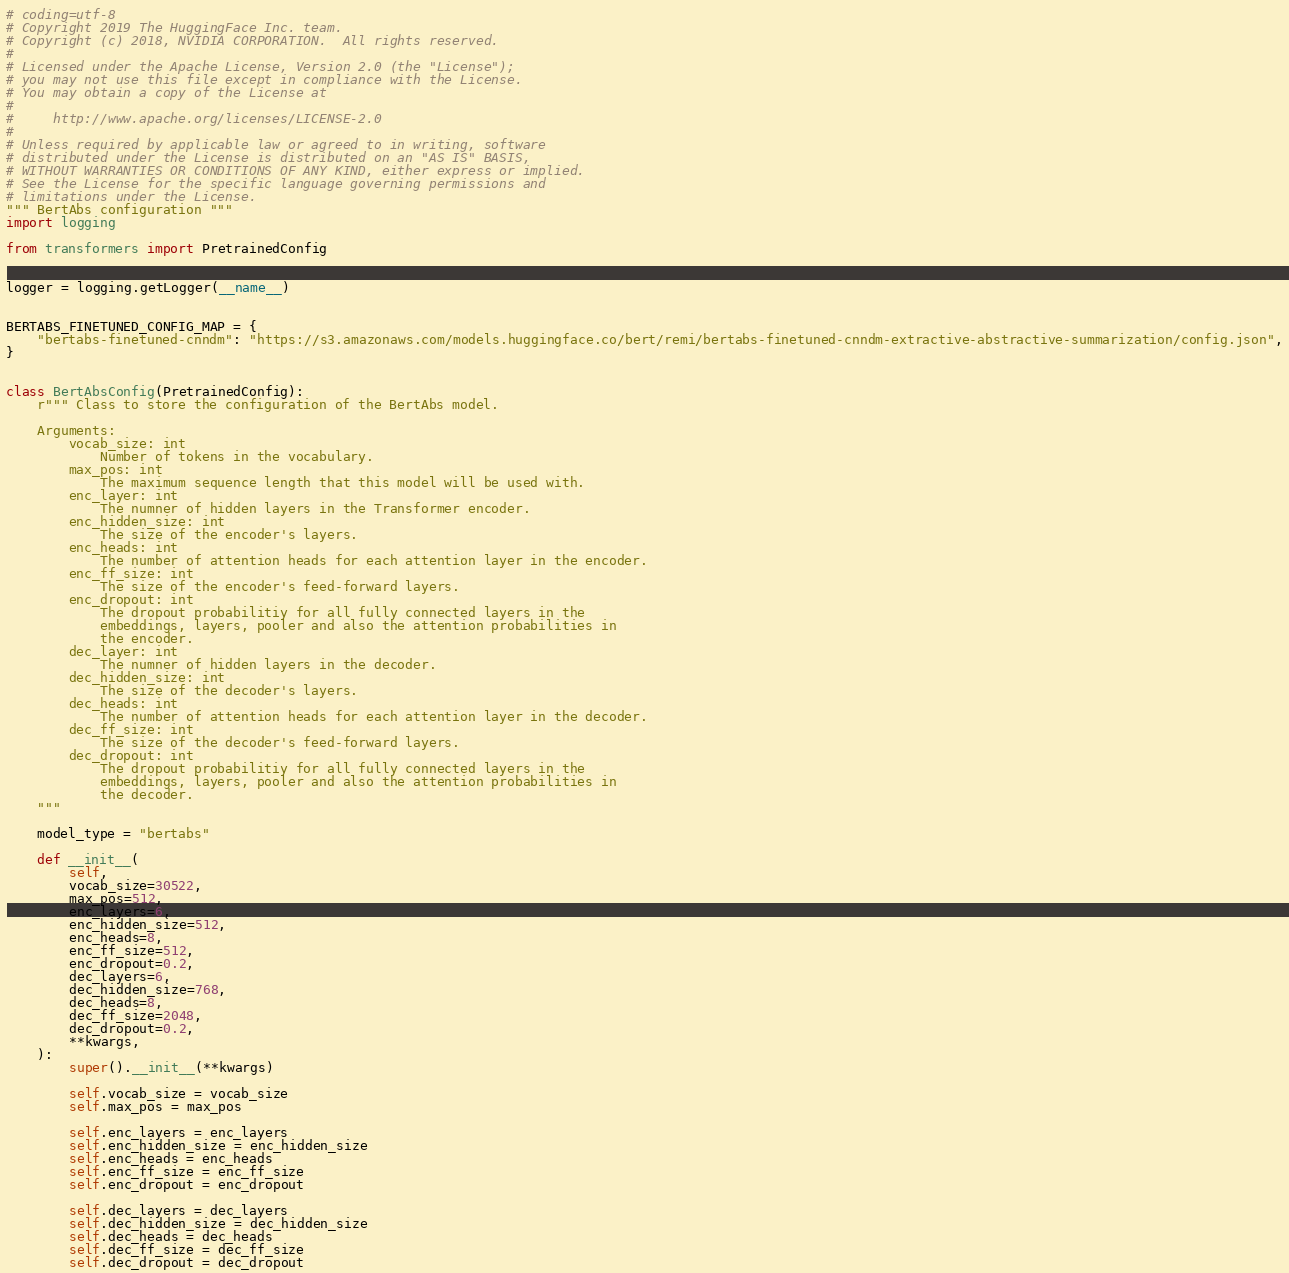<code> <loc_0><loc_0><loc_500><loc_500><_Python_># coding=utf-8
# Copyright 2019 The HuggingFace Inc. team.
# Copyright (c) 2018, NVIDIA CORPORATION.  All rights reserved.
#
# Licensed under the Apache License, Version 2.0 (the "License");
# you may not use this file except in compliance with the License.
# You may obtain a copy of the License at
#
#     http://www.apache.org/licenses/LICENSE-2.0
#
# Unless required by applicable law or agreed to in writing, software
# distributed under the License is distributed on an "AS IS" BASIS,
# WITHOUT WARRANTIES OR CONDITIONS OF ANY KIND, either express or implied.
# See the License for the specific language governing permissions and
# limitations under the License.
""" BertAbs configuration """
import logging

from transformers import PretrainedConfig


logger = logging.getLogger(__name__)


BERTABS_FINETUNED_CONFIG_MAP = {
    "bertabs-finetuned-cnndm": "https://s3.amazonaws.com/models.huggingface.co/bert/remi/bertabs-finetuned-cnndm-extractive-abstractive-summarization/config.json",
}


class BertAbsConfig(PretrainedConfig):
    r""" Class to store the configuration of the BertAbs model.

    Arguments:
        vocab_size: int
            Number of tokens in the vocabulary.
        max_pos: int
            The maximum sequence length that this model will be used with.
        enc_layer: int
            The numner of hidden layers in the Transformer encoder.
        enc_hidden_size: int
            The size of the encoder's layers.
        enc_heads: int
            The number of attention heads for each attention layer in the encoder.
        enc_ff_size: int
            The size of the encoder's feed-forward layers.
        enc_dropout: int
            The dropout probabilitiy for all fully connected layers in the
            embeddings, layers, pooler and also the attention probabilities in
            the encoder.
        dec_layer: int
            The numner of hidden layers in the decoder.
        dec_hidden_size: int
            The size of the decoder's layers.
        dec_heads: int
            The number of attention heads for each attention layer in the decoder.
        dec_ff_size: int
            The size of the decoder's feed-forward layers.
        dec_dropout: int
            The dropout probabilitiy for all fully connected layers in the
            embeddings, layers, pooler and also the attention probabilities in
            the decoder.
    """

    model_type = "bertabs"

    def __init__(
        self,
        vocab_size=30522,
        max_pos=512,
        enc_layers=6,
        enc_hidden_size=512,
        enc_heads=8,
        enc_ff_size=512,
        enc_dropout=0.2,
        dec_layers=6,
        dec_hidden_size=768,
        dec_heads=8,
        dec_ff_size=2048,
        dec_dropout=0.2,
        **kwargs,
    ):
        super().__init__(**kwargs)

        self.vocab_size = vocab_size
        self.max_pos = max_pos

        self.enc_layers = enc_layers
        self.enc_hidden_size = enc_hidden_size
        self.enc_heads = enc_heads
        self.enc_ff_size = enc_ff_size
        self.enc_dropout = enc_dropout

        self.dec_layers = dec_layers
        self.dec_hidden_size = dec_hidden_size
        self.dec_heads = dec_heads
        self.dec_ff_size = dec_ff_size
        self.dec_dropout = dec_dropout
</code> 